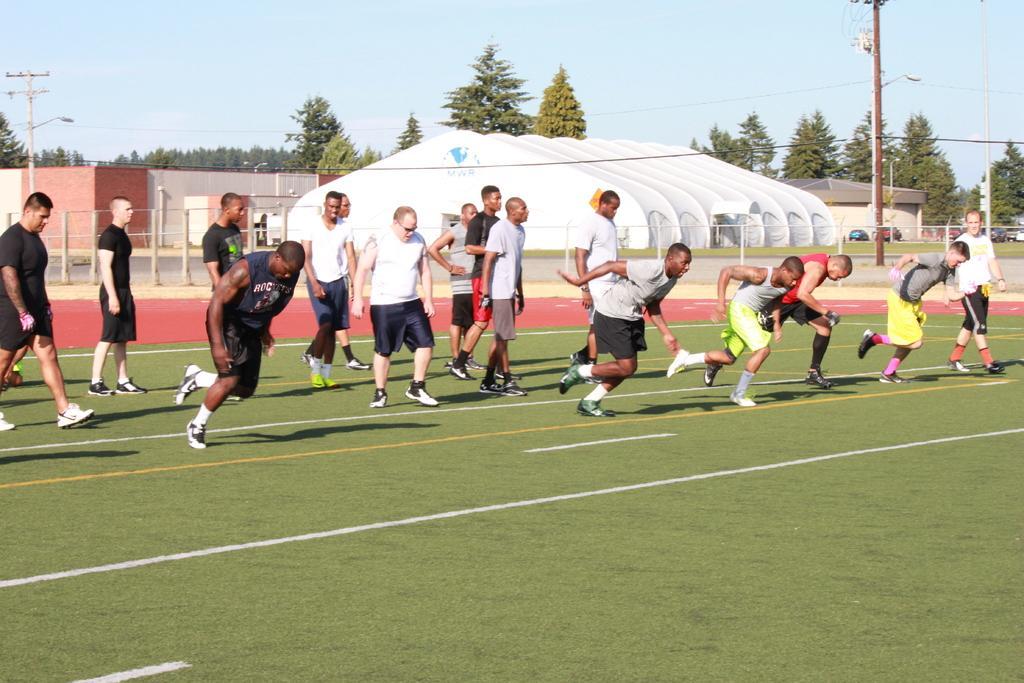Can you describe this image briefly? In this image there are a few people running on the ground and few are standing, behind them there are buildings, poles, a few vehicles are parked, utility poles and the sky. 